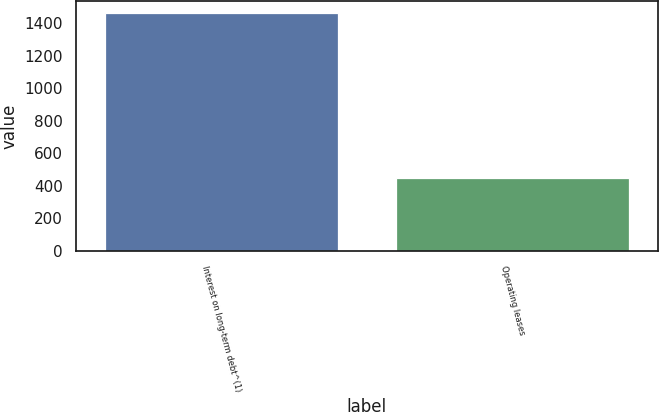<chart> <loc_0><loc_0><loc_500><loc_500><bar_chart><fcel>Interest on long-term debt^(1)<fcel>Operating leases<nl><fcel>1464<fcel>448<nl></chart> 